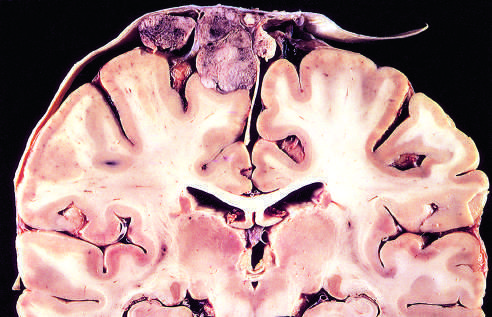s a pacemaker attached to the dura with compression of underlying brain?
Answer the question using a single word or phrase. No 